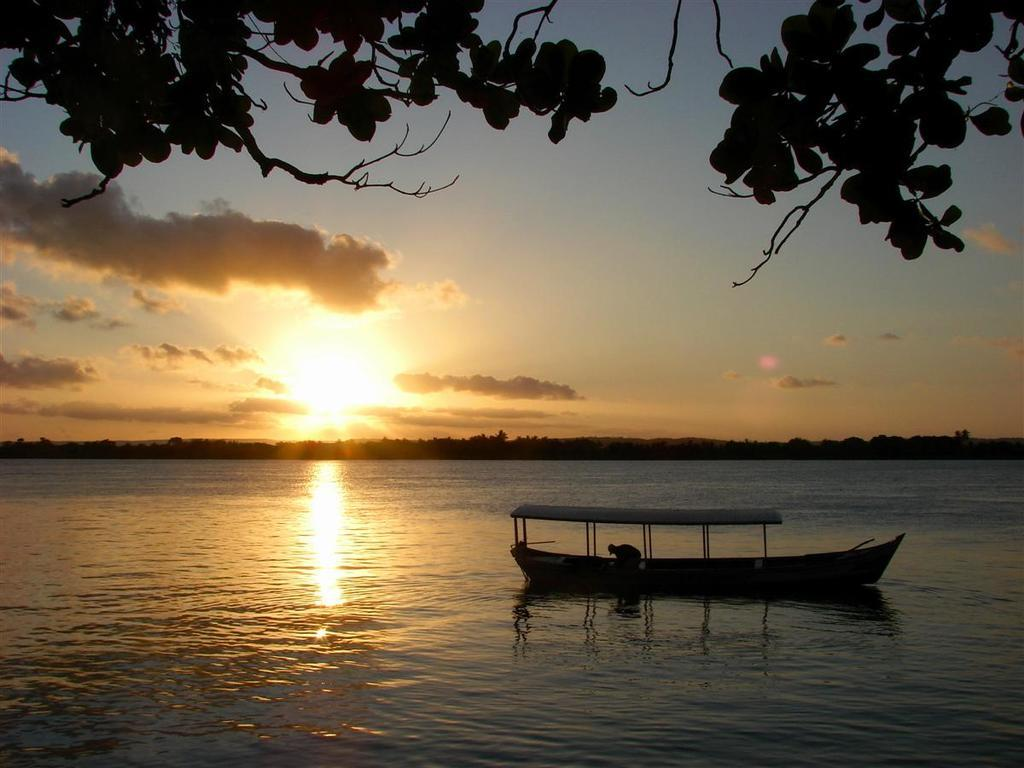Who is on the boat in the image? There is a person on the boat in the image. What is the boat's location in relation to the water? The boat is on the water in the image. What can be seen in the background of the image? There are trees and the sky visible in the background of the image. What is the condition of the sky in the image? The sky has clouds in the image. What is at the top of the image? There are branches with leaves at the top of the image. What grade did the person on the boat receive in their last exam? There is no information about the person's grades or exams in the image. 